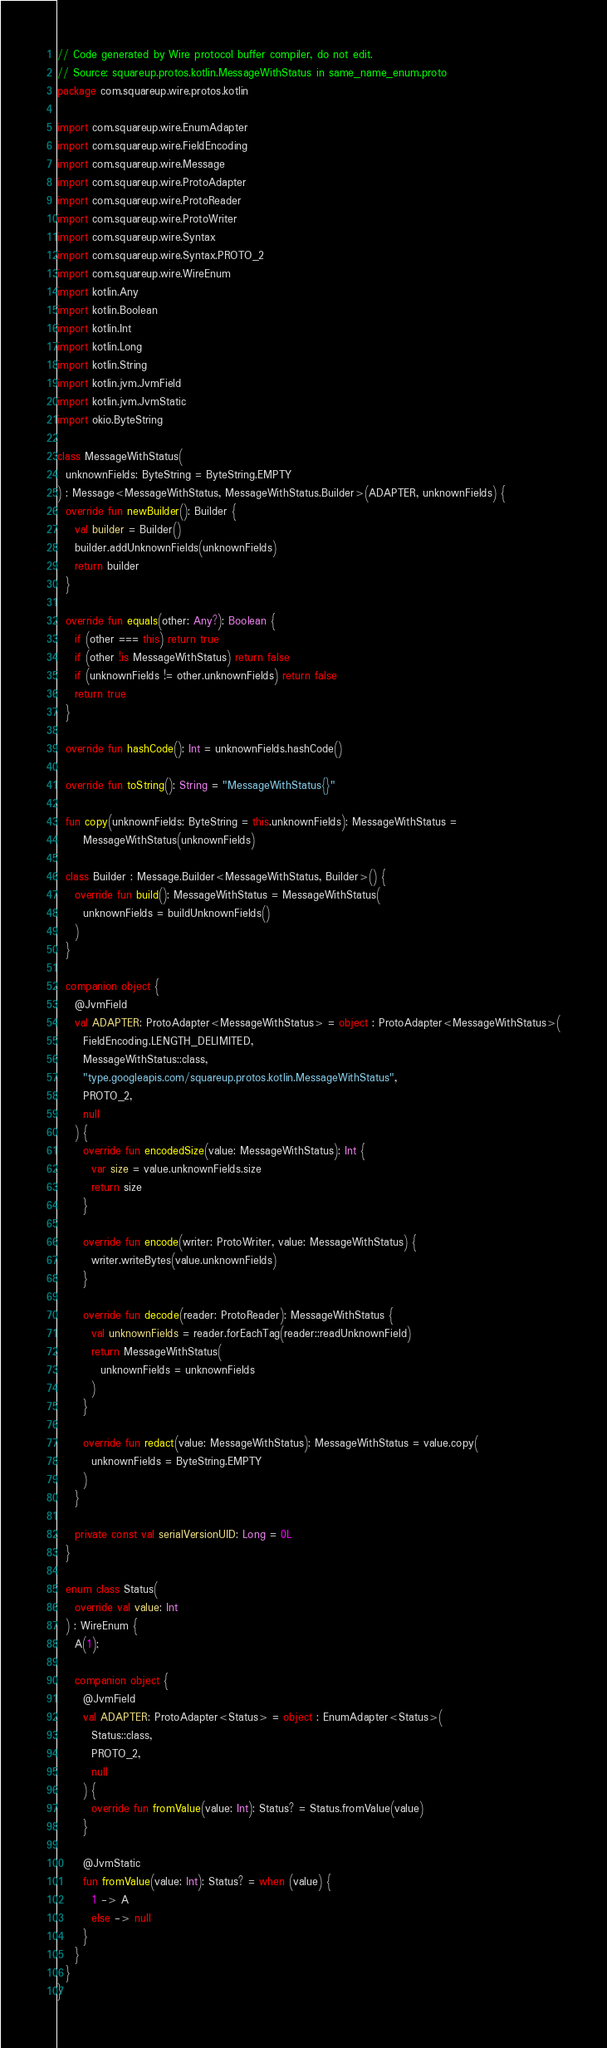<code> <loc_0><loc_0><loc_500><loc_500><_Kotlin_>// Code generated by Wire protocol buffer compiler, do not edit.
// Source: squareup.protos.kotlin.MessageWithStatus in same_name_enum.proto
package com.squareup.wire.protos.kotlin

import com.squareup.wire.EnumAdapter
import com.squareup.wire.FieldEncoding
import com.squareup.wire.Message
import com.squareup.wire.ProtoAdapter
import com.squareup.wire.ProtoReader
import com.squareup.wire.ProtoWriter
import com.squareup.wire.Syntax
import com.squareup.wire.Syntax.PROTO_2
import com.squareup.wire.WireEnum
import kotlin.Any
import kotlin.Boolean
import kotlin.Int
import kotlin.Long
import kotlin.String
import kotlin.jvm.JvmField
import kotlin.jvm.JvmStatic
import okio.ByteString

class MessageWithStatus(
  unknownFields: ByteString = ByteString.EMPTY
) : Message<MessageWithStatus, MessageWithStatus.Builder>(ADAPTER, unknownFields) {
  override fun newBuilder(): Builder {
    val builder = Builder()
    builder.addUnknownFields(unknownFields)
    return builder
  }

  override fun equals(other: Any?): Boolean {
    if (other === this) return true
    if (other !is MessageWithStatus) return false
    if (unknownFields != other.unknownFields) return false
    return true
  }

  override fun hashCode(): Int = unknownFields.hashCode()

  override fun toString(): String = "MessageWithStatus{}"

  fun copy(unknownFields: ByteString = this.unknownFields): MessageWithStatus =
      MessageWithStatus(unknownFields)

  class Builder : Message.Builder<MessageWithStatus, Builder>() {
    override fun build(): MessageWithStatus = MessageWithStatus(
      unknownFields = buildUnknownFields()
    )
  }

  companion object {
    @JvmField
    val ADAPTER: ProtoAdapter<MessageWithStatus> = object : ProtoAdapter<MessageWithStatus>(
      FieldEncoding.LENGTH_DELIMITED, 
      MessageWithStatus::class, 
      "type.googleapis.com/squareup.protos.kotlin.MessageWithStatus", 
      PROTO_2, 
      null
    ) {
      override fun encodedSize(value: MessageWithStatus): Int {
        var size = value.unknownFields.size
        return size
      }

      override fun encode(writer: ProtoWriter, value: MessageWithStatus) {
        writer.writeBytes(value.unknownFields)
      }

      override fun decode(reader: ProtoReader): MessageWithStatus {
        val unknownFields = reader.forEachTag(reader::readUnknownField)
        return MessageWithStatus(
          unknownFields = unknownFields
        )
      }

      override fun redact(value: MessageWithStatus): MessageWithStatus = value.copy(
        unknownFields = ByteString.EMPTY
      )
    }

    private const val serialVersionUID: Long = 0L
  }

  enum class Status(
    override val value: Int
  ) : WireEnum {
    A(1);

    companion object {
      @JvmField
      val ADAPTER: ProtoAdapter<Status> = object : EnumAdapter<Status>(
        Status::class, 
        PROTO_2, 
        null
      ) {
        override fun fromValue(value: Int): Status? = Status.fromValue(value)
      }

      @JvmStatic
      fun fromValue(value: Int): Status? = when (value) {
        1 -> A
        else -> null
      }
    }
  }
}
</code> 